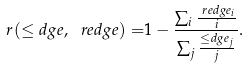<formula> <loc_0><loc_0><loc_500><loc_500>r ( \leq d g e , \ r e d g e ) = & 1 - \frac { \sum _ { i } \frac { \ r e d g e _ { i } } { i } } { \sum _ { j } \frac { \leq d g e _ { j } } { j } } .</formula> 